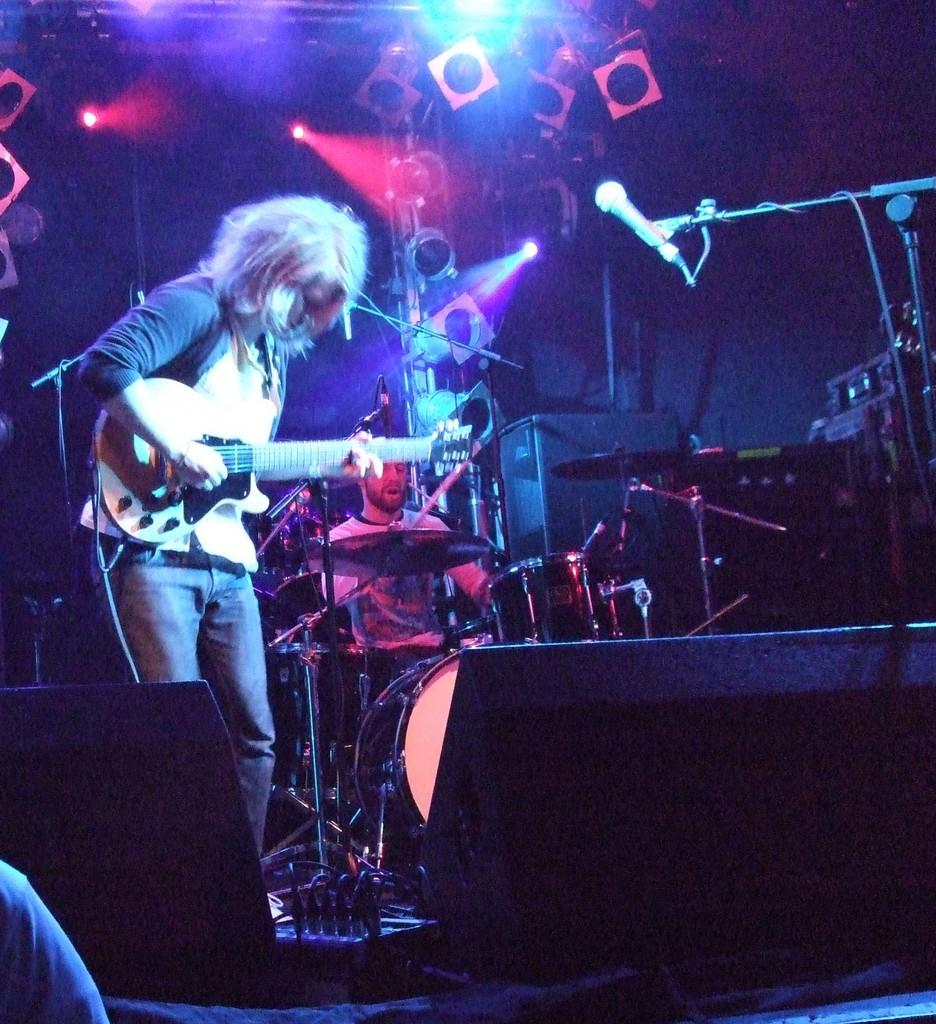How many people are in the image? There are two people in the image. What are the two people doing in the image? The two people are playing musical instruments. What else can be seen in the image besides the people and their instruments? There are devices visible in the image. What can be seen in the background of the image? There are focusing lights in the background of the image. What color is the banana being worn by the person on the left in the image? There is no banana present in the image, and the people are not wearing any clothing items resembling a banana. 